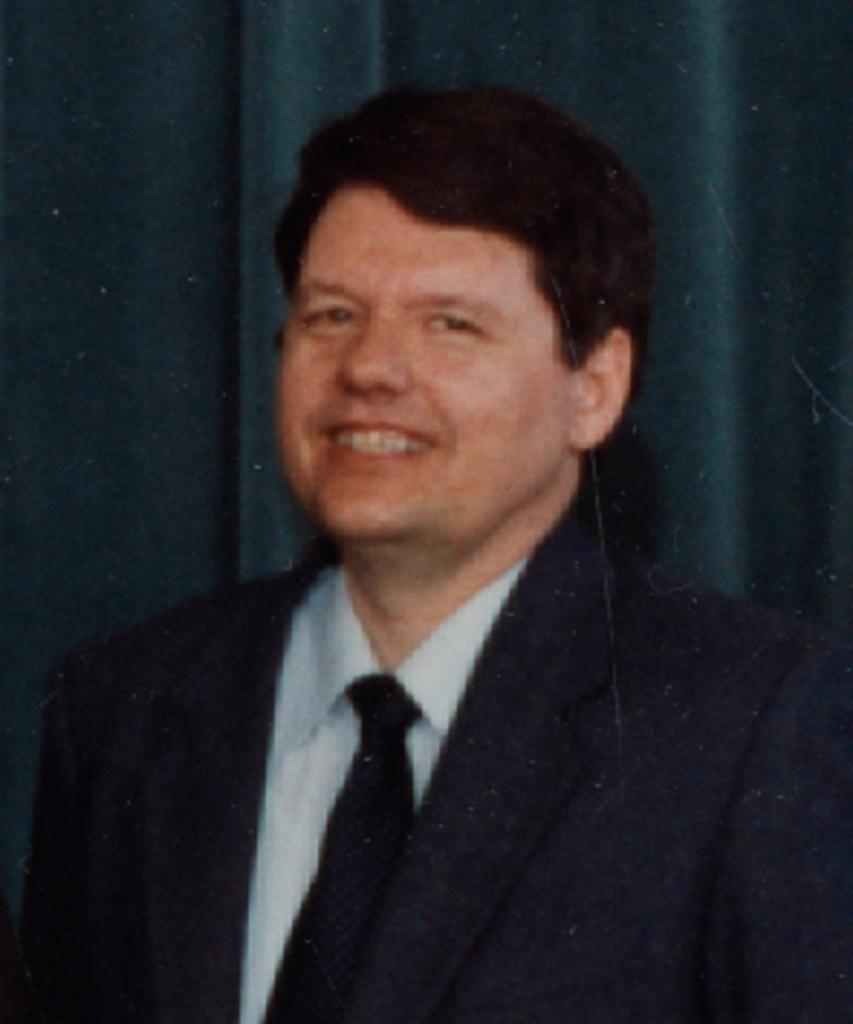In one or two sentences, can you explain what this image depicts? In this image I can see the person is wearing black and white dress and the tie is in black color. Background I can see the curtain. 